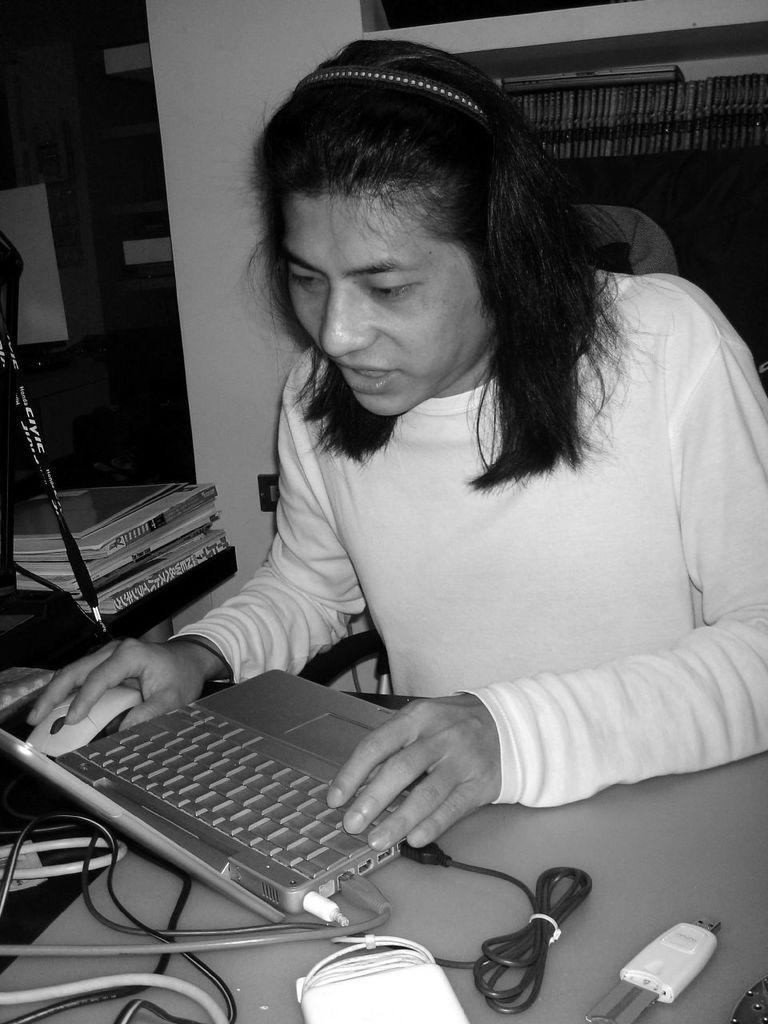What is the woman in the image doing? The woman is sitting on a chair and working on her laptop. What objects can be seen on the table in the image? There are cables, a laptop, and a mouse on the table. What is stored on the rack in the image? The rack is filled with books. Are there any books visible in the image? Yes, there are books visible in the image. What type of tax is being discussed in the image? There is no discussion of tax in the image; it features a woman working on her laptop and books on a rack. What is the woman doing to the sack in the image? There is no sack present in the image, and the woman is working on her laptop, not interacting with any sacks. 